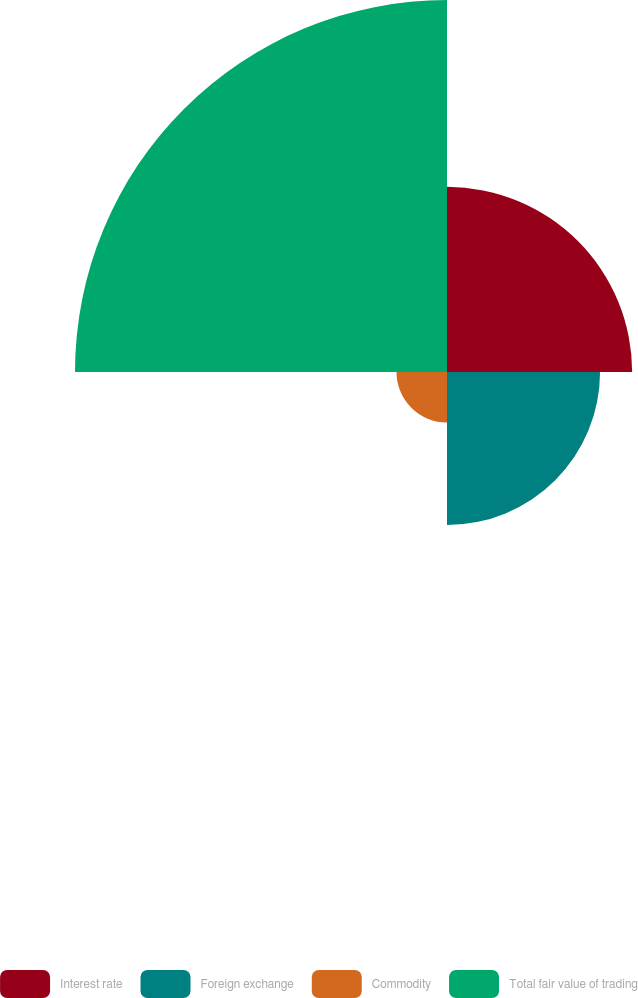<chart> <loc_0><loc_0><loc_500><loc_500><pie_chart><fcel>Interest rate<fcel>Foreign exchange<fcel>Commodity<fcel>Total fair value of trading<nl><fcel>24.34%<fcel>20.12%<fcel>6.64%<fcel>48.9%<nl></chart> 